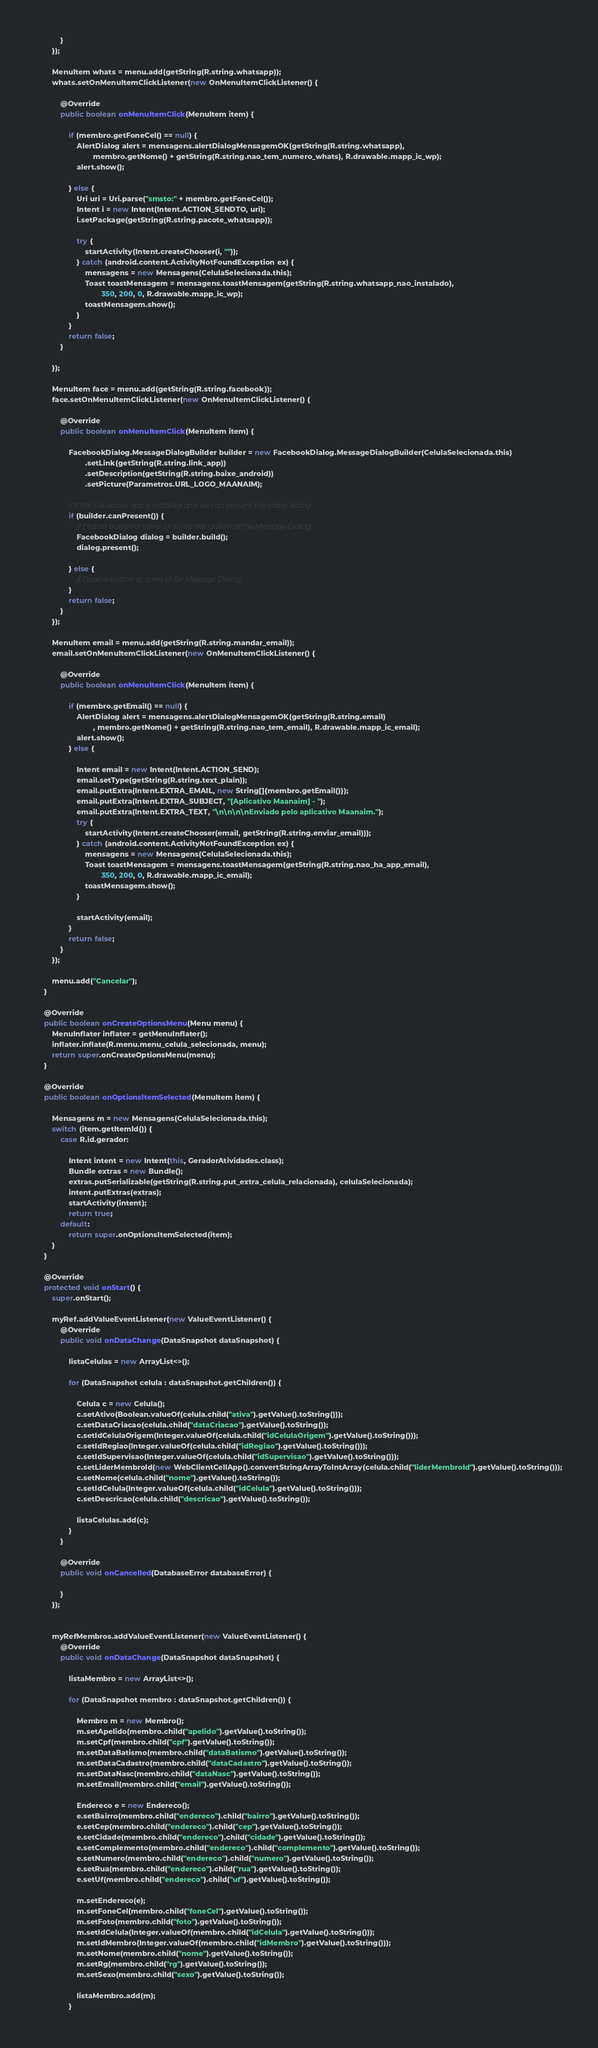Convert code to text. <code><loc_0><loc_0><loc_500><loc_500><_Java_>            }
        });

        MenuItem whats = menu.add(getString(R.string.whatsapp));
        whats.setOnMenuItemClickListener(new OnMenuItemClickListener() {

            @Override
            public boolean onMenuItemClick(MenuItem item) {

                if (membro.getFoneCel() == null) {
                    AlertDialog alert = mensagens.alertDialogMensagemOK(getString(R.string.whatsapp),
                            membro.getNome() + getString(R.string.nao_tem_numero_whats), R.drawable.mapp_ic_wp);
                    alert.show();

                } else {
                    Uri uri = Uri.parse("smsto:" + membro.getFoneCel());
                    Intent i = new Intent(Intent.ACTION_SENDTO, uri);
                    i.setPackage(getString(R.string.pacote_whatsapp));

                    try {
                        startActivity(Intent.createChooser(i, ""));
                    } catch (android.content.ActivityNotFoundException ex) {
                        mensagens = new Mensagens(CelulaSelecionada.this);
                        Toast toastMensagem = mensagens.toastMensagem(getString(R.string.whatsapp_nao_instalado),
                                350, 200, 0, R.drawable.mapp_ic_wp);
                        toastMensagem.show();
                    }
                }
                return false;
            }

        });

        MenuItem face = menu.add(getString(R.string.facebook));
        face.setOnMenuItemClickListener(new OnMenuItemClickListener() {

            @Override
            public boolean onMenuItemClick(MenuItem item) {

                FacebookDialog.MessageDialogBuilder builder = new FacebookDialog.MessageDialogBuilder(CelulaSelecionada.this)
                        .setLink(getString(R.string.link_app))
                        .setDescription(getString(R.string.baixe_android))
                        .setPicture(Parametros.URL_LOGO_MAANAIM);

                // If the Facebook app is installed and we can present the share dialog
                if (builder.canPresent()) {
                    // Enable button or other UI to initiate launch of the Message Dialog
                    FacebookDialog dialog = builder.build();
                    dialog.present();

                } else {
                    // Disable button or other UI for Message Dialog
                }
                return false;
            }
        });

        MenuItem email = menu.add(getString(R.string.mandar_email));
        email.setOnMenuItemClickListener(new OnMenuItemClickListener() {

            @Override
            public boolean onMenuItemClick(MenuItem item) {

                if (membro.getEmail() == null) {
                    AlertDialog alert = mensagens.alertDialogMensagemOK(getString(R.string.email)
                            , membro.getNome() + getString(R.string.nao_tem_email), R.drawable.mapp_ic_email);
                    alert.show();
                } else {

                    Intent email = new Intent(Intent.ACTION_SEND);
                    email.setType(getString(R.string.text_plain));
                    email.putExtra(Intent.EXTRA_EMAIL, new String[]{membro.getEmail()});
                    email.putExtra(Intent.EXTRA_SUBJECT, "[Aplicativo Maanaim] - ");
                    email.putExtra(Intent.EXTRA_TEXT, "\n\n\n\nEnviado pelo aplicativo Maanaim.");
                    try {
                        startActivity(Intent.createChooser(email, getString(R.string.enviar_email)));
                    } catch (android.content.ActivityNotFoundException ex) {
                        mensagens = new Mensagens(CelulaSelecionada.this);
                        Toast toastMensagem = mensagens.toastMensagem(getString(R.string.nao_ha_app_email),
                                350, 200, 0, R.drawable.mapp_ic_email);
                        toastMensagem.show();
                    }

                    startActivity(email);
                }
                return false;
            }
        });

        menu.add("Cancelar");
    }

    @Override
    public boolean onCreateOptionsMenu(Menu menu) {
        MenuInflater inflater = getMenuInflater();
        inflater.inflate(R.menu.menu_celula_selecionada, menu);
        return super.onCreateOptionsMenu(menu);
    }

    @Override
    public boolean onOptionsItemSelected(MenuItem item) {

        Mensagens m = new Mensagens(CelulaSelecionada.this);
        switch (item.getItemId()) {
            case R.id.gerador:

                Intent intent = new Intent(this, GeradorAtividades.class);
                Bundle extras = new Bundle();
                extras.putSerializable(getString(R.string.put_extra_celula_relacionada), celulaSelecionada);
                intent.putExtras(extras);
                startActivity(intent);
                return true;
            default:
                return super.onOptionsItemSelected(item);
        }
    }

    @Override
    protected void onStart() {
        super.onStart();

        myRef.addValueEventListener(new ValueEventListener() {
            @Override
            public void onDataChange(DataSnapshot dataSnapshot) {

                listaCelulas = new ArrayList<>();

                for (DataSnapshot celula : dataSnapshot.getChildren()) {

                    Celula c = new Celula();
                    c.setAtivo(Boolean.valueOf(celula.child("ativa").getValue().toString()));
                    c.setDataCriacao(celula.child("dataCriacao").getValue().toString());
                    c.setIdCelulaOrigem(Integer.valueOf(celula.child("idCelulaOrigem").getValue().toString()));
                    c.setIdRegiao(Integer.valueOf(celula.child("idRegiao").getValue().toString()));
                    c.setIdSupervisao(Integer.valueOf(celula.child("idSupervisao").getValue().toString()));
                    c.setLiderMembroId(new WebClientCellApp().convertStringArrayToIntArray(celula.child("liderMembroId").getValue().toString()));
                    c.setNome(celula.child("nome").getValue().toString());
                    c.setIdCelula(Integer.valueOf(celula.child("idCelula").getValue().toString()));
                    c.setDescricao(celula.child("descricao").getValue().toString());

                    listaCelulas.add(c);
                }
            }

            @Override
            public void onCancelled(DatabaseError databaseError) {

            }
        });


        myRefMembros.addValueEventListener(new ValueEventListener() {
            @Override
            public void onDataChange(DataSnapshot dataSnapshot) {

                listaMembro = new ArrayList<>();

                for (DataSnapshot membro : dataSnapshot.getChildren()) {

                    Membro m = new Membro();
                    m.setApelido(membro.child("apelido").getValue().toString());
                    m.setCpf(membro.child("cpf").getValue().toString());
                    m.setDataBatismo(membro.child("dataBatismo").getValue().toString());
                    m.setDataCadastro(membro.child("dataCadastro").getValue().toString());
                    m.setDataNasc(membro.child("dataNasc").getValue().toString());
                    m.setEmail(membro.child("email").getValue().toString());

                    Endereco e = new Endereco();
                    e.setBairro(membro.child("endereco").child("bairro").getValue().toString());
                    e.setCep(membro.child("endereco").child("cep").getValue().toString());
                    e.setCidade(membro.child("endereco").child("cidade").getValue().toString());
                    e.setComplemento(membro.child("endereco").child("complemento").getValue().toString());
                    e.setNumero(membro.child("endereco").child("numero").getValue().toString());
                    e.setRua(membro.child("endereco").child("rua").getValue().toString());
                    e.setUf(membro.child("endereco").child("uf").getValue().toString());

                    m.setEndereco(e);
                    m.setFoneCel(membro.child("foneCel").getValue().toString());
                    m.setFoto(membro.child("foto").getValue().toString());
                    m.setIdCelula(Integer.valueOf(membro.child("idCelula").getValue().toString()));
                    m.setIdMembro(Integer.valueOf(membro.child("idMembro").getValue().toString()));
                    m.setNome(membro.child("nome").getValue().toString());
                    m.setRg(membro.child("rg").getValue().toString());
                    m.setSexo(membro.child("sexo").getValue().toString());

                    listaMembro.add(m);
                }
</code> 